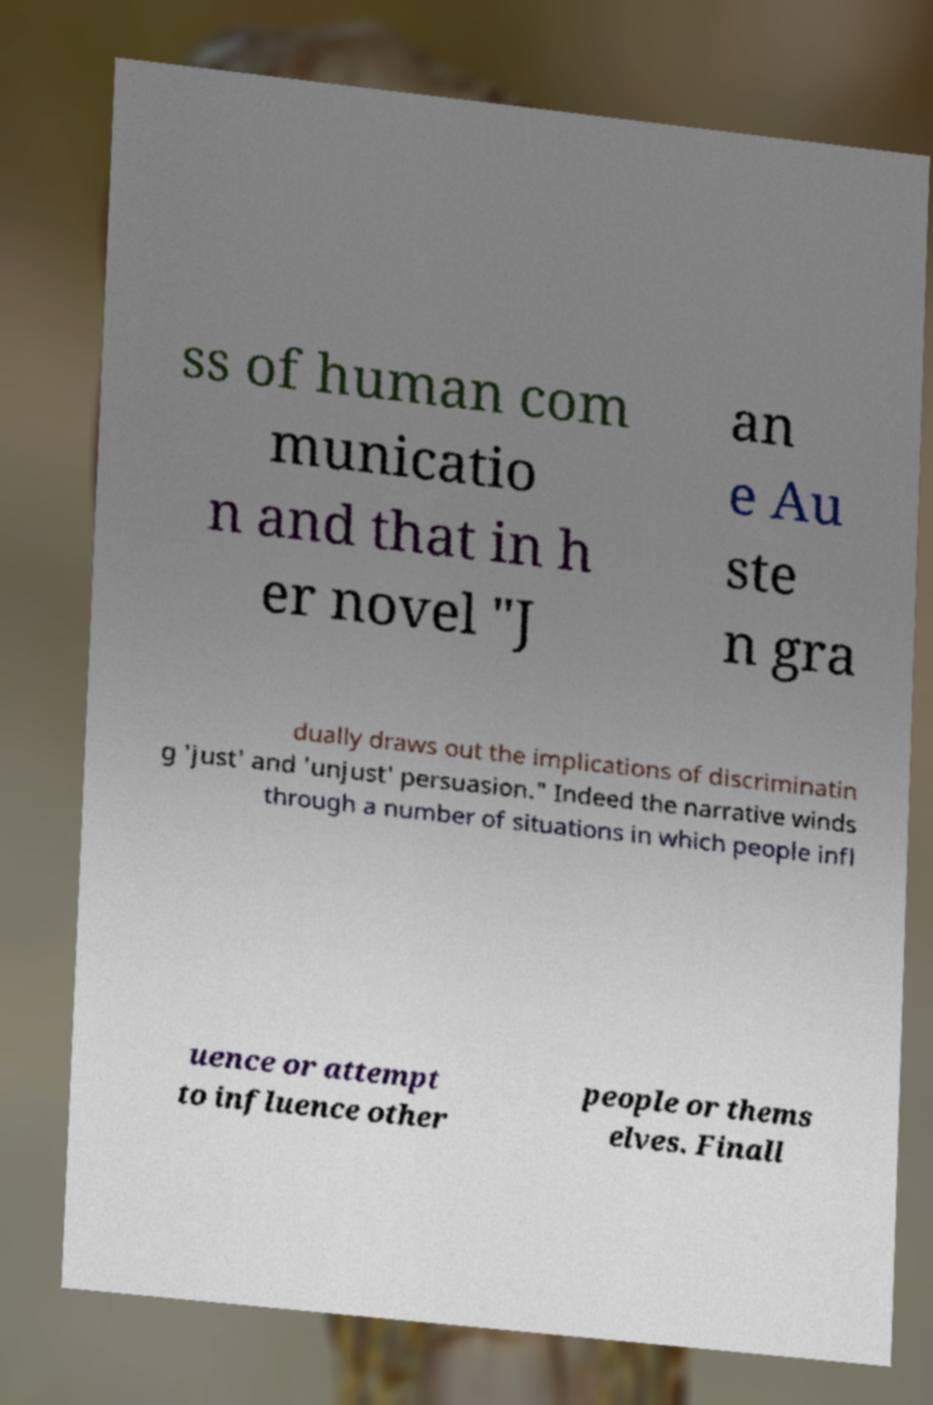Could you extract and type out the text from this image? ss of human com municatio n and that in h er novel "J an e Au ste n gra dually draws out the implications of discriminatin g 'just' and 'unjust' persuasion." Indeed the narrative winds through a number of situations in which people infl uence or attempt to influence other people or thems elves. Finall 